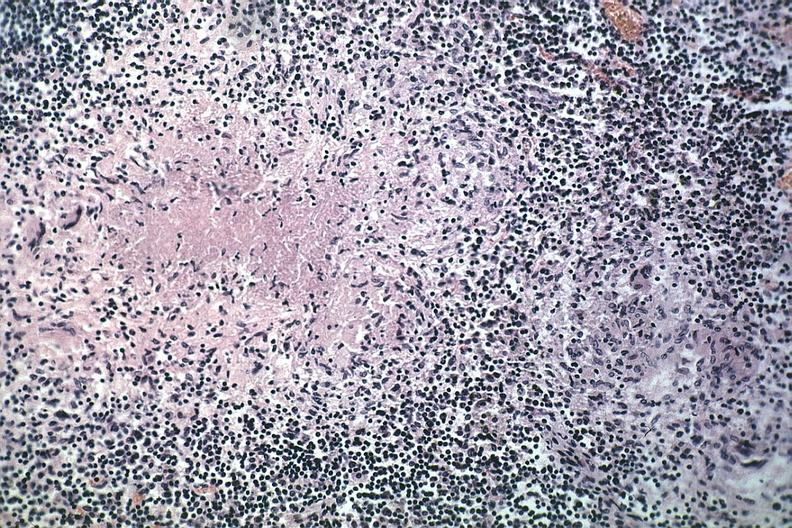what is present?
Answer the question using a single word or phrase. Lymph node 